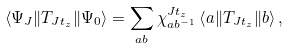<formula> <loc_0><loc_0><loc_500><loc_500>\left \langle \Psi _ { J } \| T _ { J t _ { z } } \| \Psi _ { 0 } \right \rangle = \sum _ { a b } \chi ^ { J t _ { z } } _ { a b ^ { - 1 } } \left \langle a \| T _ { J t _ { z } } \| b \right \rangle ,</formula> 